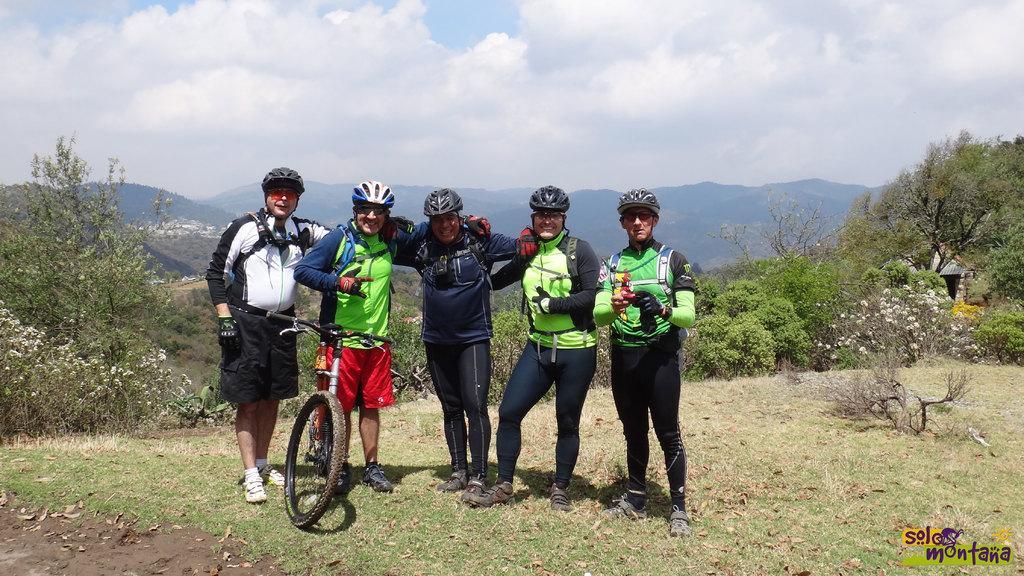Can you describe this image briefly? In this image we can see a group of people standing on the ground wearing helmets. One person wearing white shirt and goggles. One person wearing green dress is standing beside a bicycle. in the background, we can see a building, group of trees, mountains and a cloudy sky. 